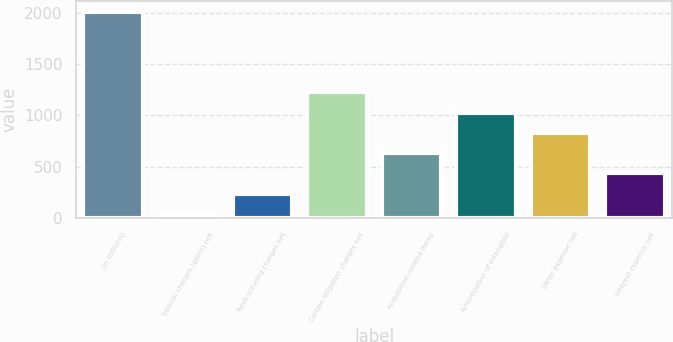<chart> <loc_0><loc_0><loc_500><loc_500><bar_chart><fcel>(in millions)<fcel>Special charges (gains) net<fcel>Restructuring charges net<fcel>Certain litigation charges net<fcel>Acquisition-related items<fcel>Amortization of intangible<fcel>Other expense net<fcel>Interest expense net<nl><fcel>2014<fcel>40<fcel>237.4<fcel>1224.4<fcel>632.2<fcel>1027<fcel>829.6<fcel>434.8<nl></chart> 